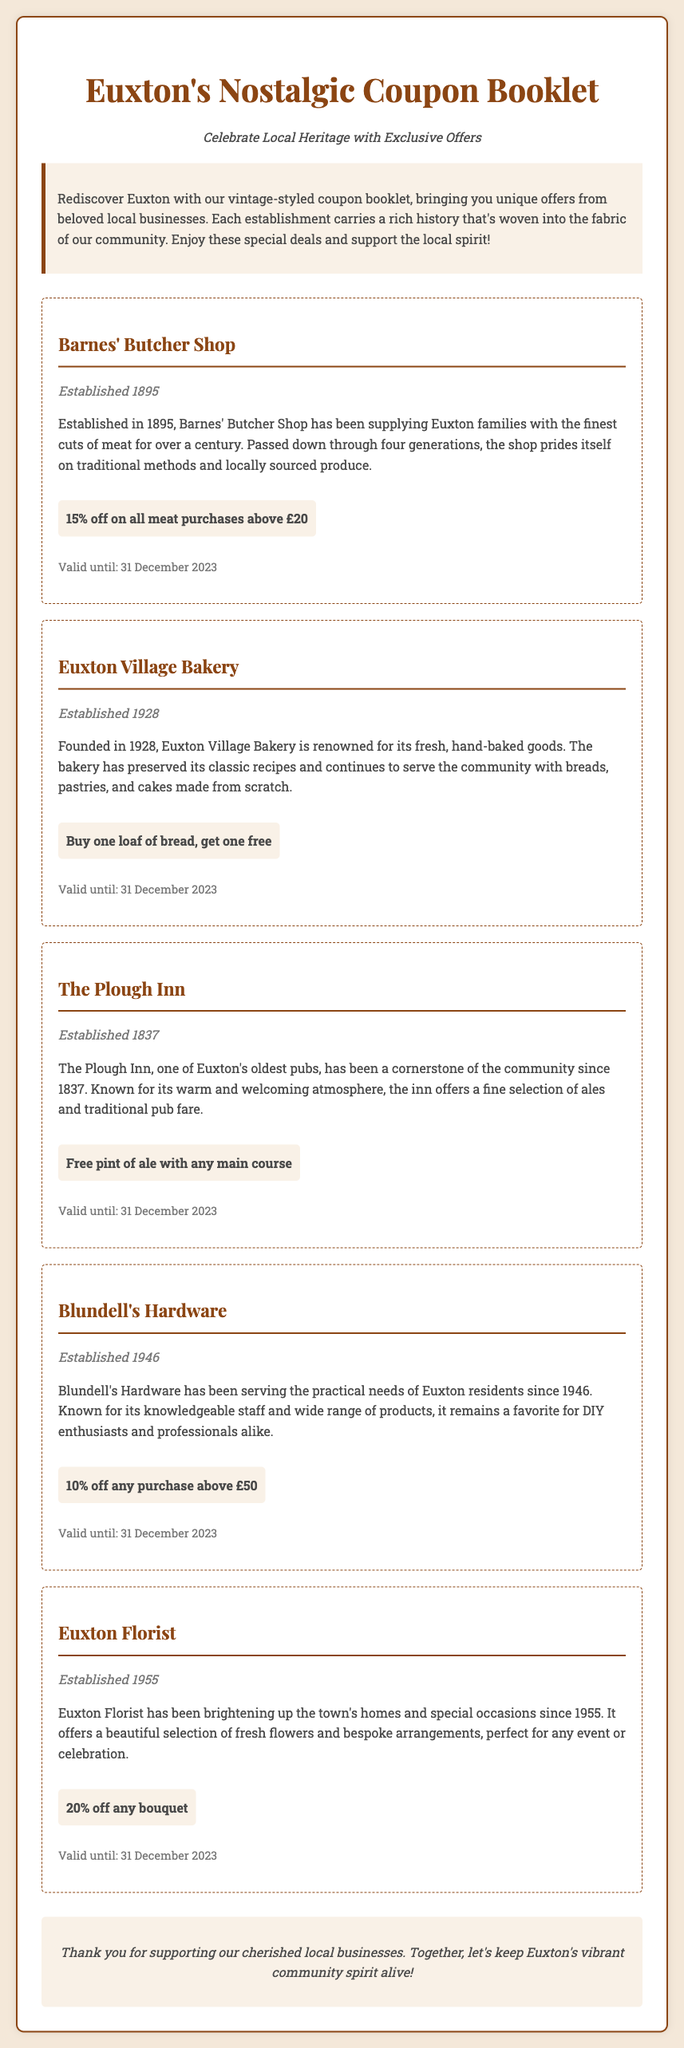What is the name of the butcher shop? The butcher shop is named Barnes' Butcher Shop, as mentioned in the document.
Answer: Barnes' Butcher Shop When was the Euxton Village Bakery established? The document states that the Euxton Village Bakery was established in 1928.
Answer: 1928 What discount does Blundell's Hardware offer? The document specifies that Blundell's Hardware offers a 10% discount on purchases above £50.
Answer: 10% off Which establishment is known for its fresh flowers? The document indicates that Euxton Florist is known for its fresh flowers.
Answer: Euxton Florist What is the expiration date for the coupon offers? The document mentions that all coupon offers are valid until 31 December 2023.
Answer: 31 December 2023 How many generations has Barnes' Butcher Shop been passed down? The document states that Barnes' Butcher Shop has been passed down through four generations.
Answer: Four generations What type of food does The Plough Inn serve? The document describes The Plough Inn as serving traditional pub fare.
Answer: Traditional pub fare Which company was established in 1946? The document notes that Blundell's Hardware was established in 1946.
Answer: Blundell's Hardware What is the special offer at Euxton Florist? The document specifies that the special offer at Euxton Florist is 20% off any bouquet.
Answer: 20% off any bouquet 